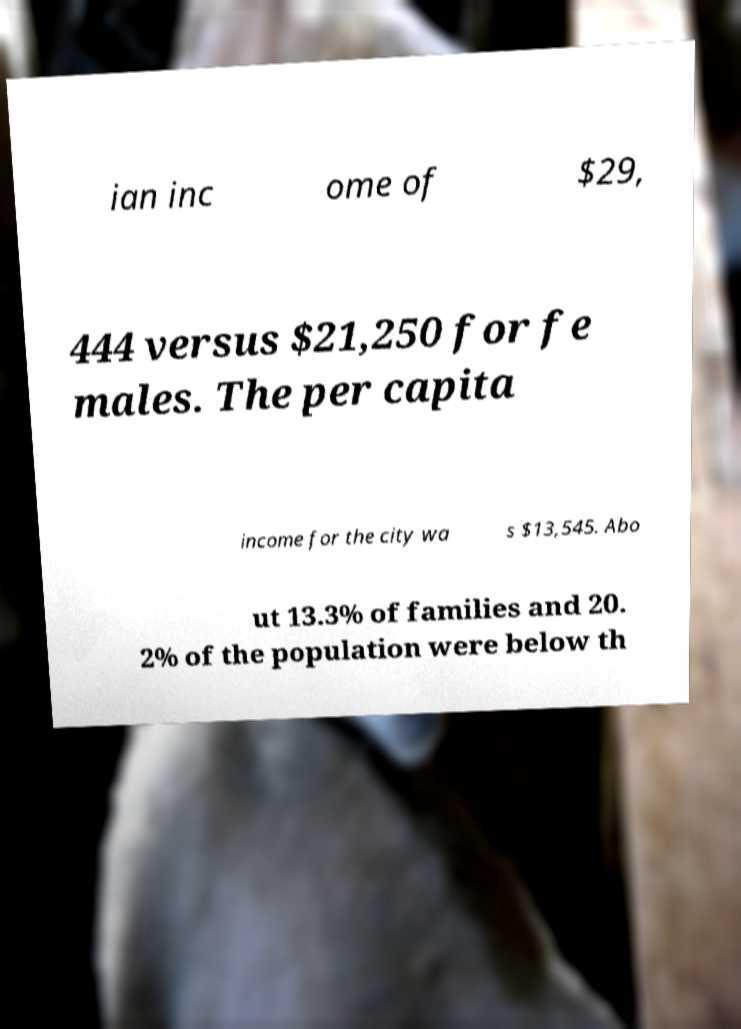I need the written content from this picture converted into text. Can you do that? ian inc ome of $29, 444 versus $21,250 for fe males. The per capita income for the city wa s $13,545. Abo ut 13.3% of families and 20. 2% of the population were below th 